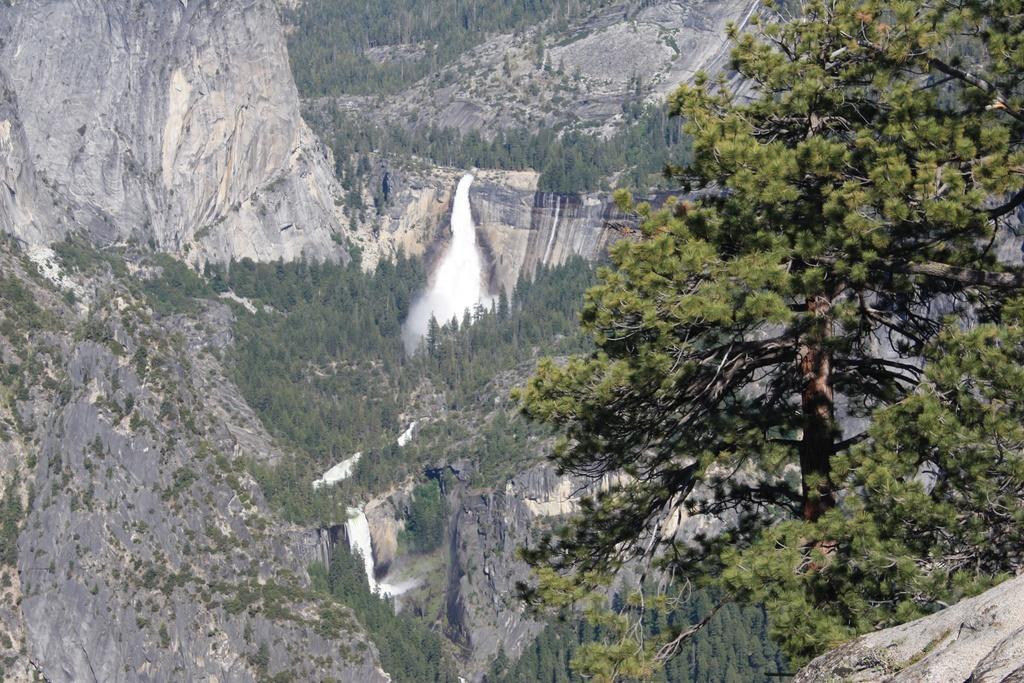Can you describe this image briefly? This picture might be taken from outside of the city. In this image, on the right side, we can see some trees. On the right corner, we can also see a stone. In the background, we can see water flowing on the rock, trees, plants. 